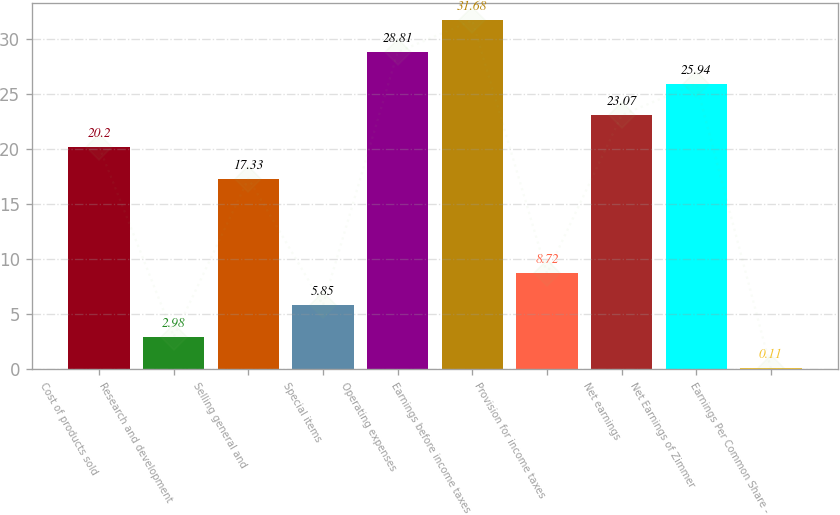Convert chart. <chart><loc_0><loc_0><loc_500><loc_500><bar_chart><fcel>Cost of products sold<fcel>Research and development<fcel>Selling general and<fcel>Special items<fcel>Operating expenses<fcel>Earnings before income taxes<fcel>Provision for income taxes<fcel>Net earnings<fcel>Net Earnings of Zimmer<fcel>Earnings Per Common Share -<nl><fcel>20.2<fcel>2.98<fcel>17.33<fcel>5.85<fcel>28.81<fcel>31.68<fcel>8.72<fcel>23.07<fcel>25.94<fcel>0.11<nl></chart> 